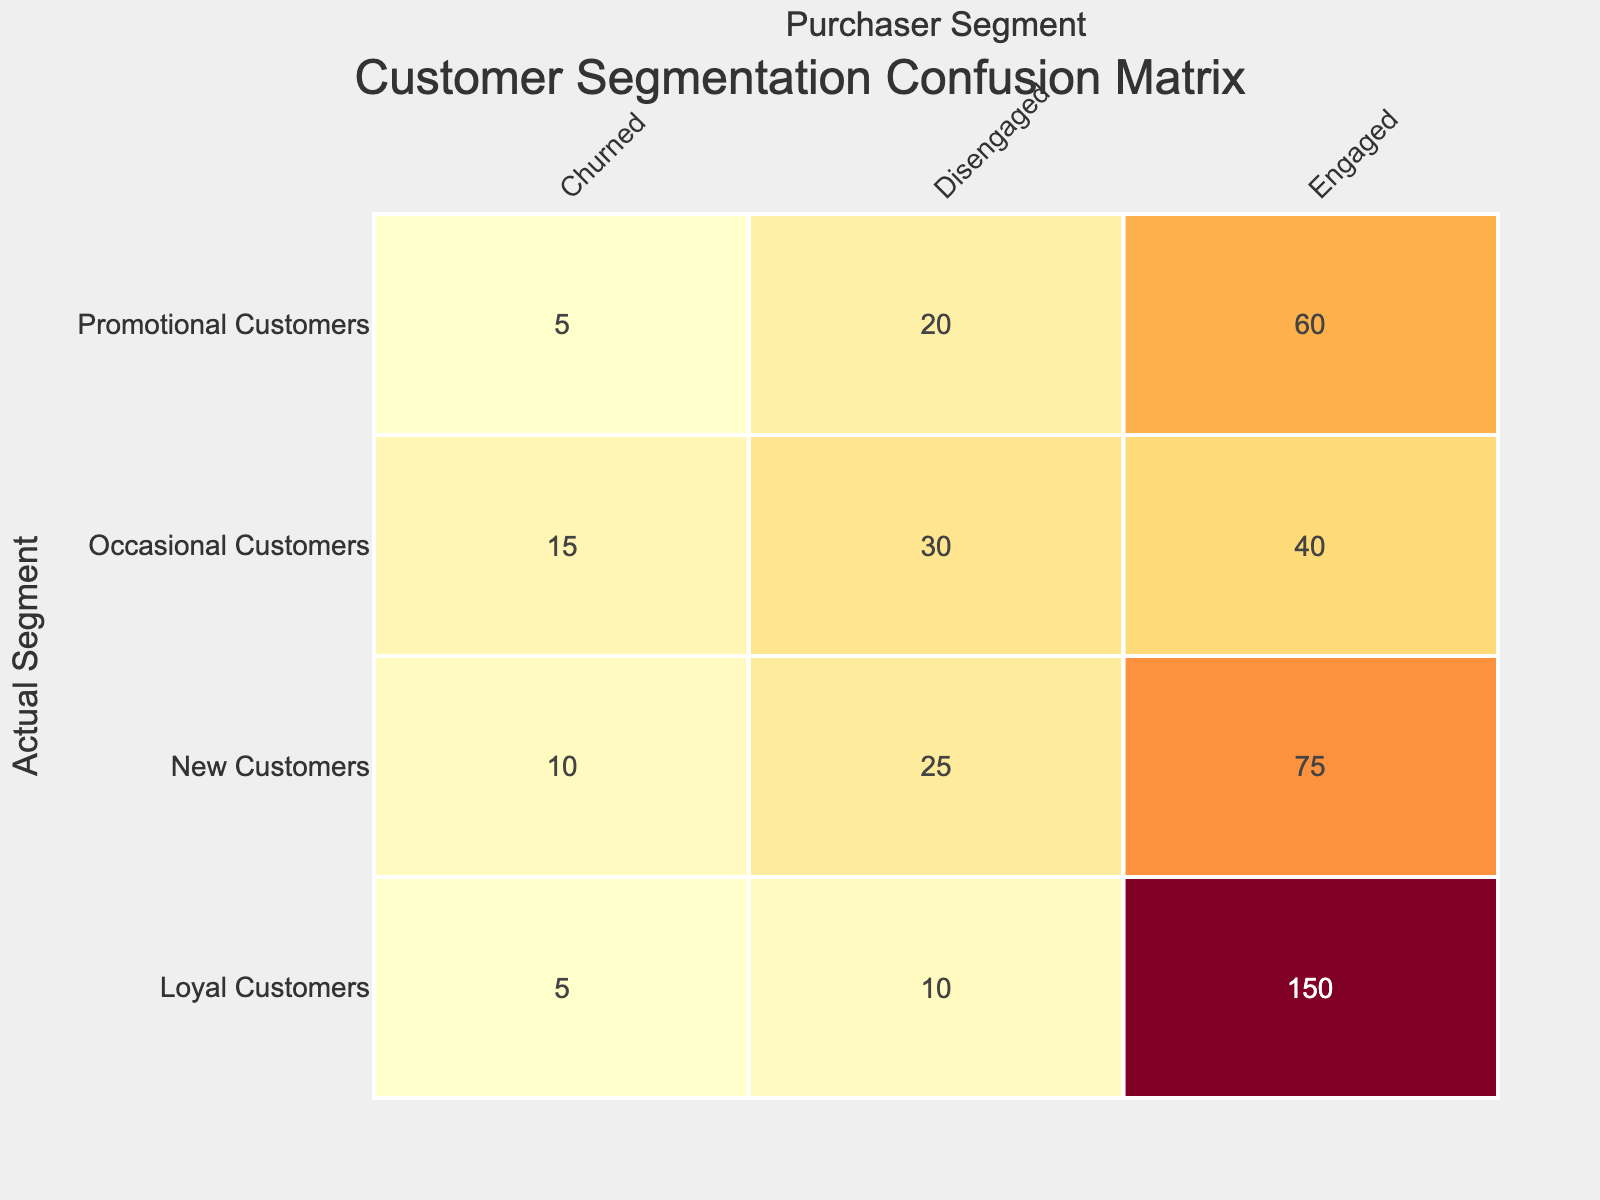What is the count of Loyal Customers who are Engaged? The table shows that the count of Loyal Customers who are Engaged is listed under the row for Loyal Customers and the column for Engaged, which is 150.
Answer: 150 How many New Customers are there in total? We can see that there are three segments for New Customers: Engaged (75), Disengaged (25), and Churned (10). Adding these up gives us 75 + 25 + 10 = 110.
Answer: 110 Are there more Occasional Customers who are Disengaged or Churned? The count for Occasional Customers who are Disengaged is 30 and for Churned is 15. Since 30 is greater than 15, the statement is true.
Answer: Yes What is the total number of Engaged Customers across all segments? To find the total, we need to add the counts of Engaged Customers from each segment: 150 (Loyal) + 75 (New) + 40 (Occasional) + 60 (Promotional) = 325.
Answer: 325 What percentage of Loyal Customers are Churned? There are 5 Loyal Customers Churned out of a total of (150 + 10 + 5) = 165 Loyal Customers. To find the percentage, we calculate (5 / 165) * 100, which is approximately 3.03%.
Answer: 3.03% Which segment has the highest count of Churned Customers? Reviewing the Churned counts: Loyal (5), New (10), Occasional (15), and Promotional (5). The highest count is from Occasional Customers, which is 15.
Answer: Occasional Customers What is the difference in count between Promotional Customers who are Engaged and those who are Disengaged? The count of Promotional Customers who are Engaged is 60 and Disengaged is 20. The difference is 60 - 20 = 40.
Answer: 40 If we combine all segments, how many customers are either Engaged or New? To find the count of customers who are either Engaged or New, we need to add the counts of Engaged Customers across all segments (325 from before) and the count of New Customers (still totaling 110 from the earlier question). Since New Customers are included in Engaged, we need only the relevant Engaged totals. Thus, the answer does not combine directly but rather states total Engaged includes New: 325.
Answer: 325 